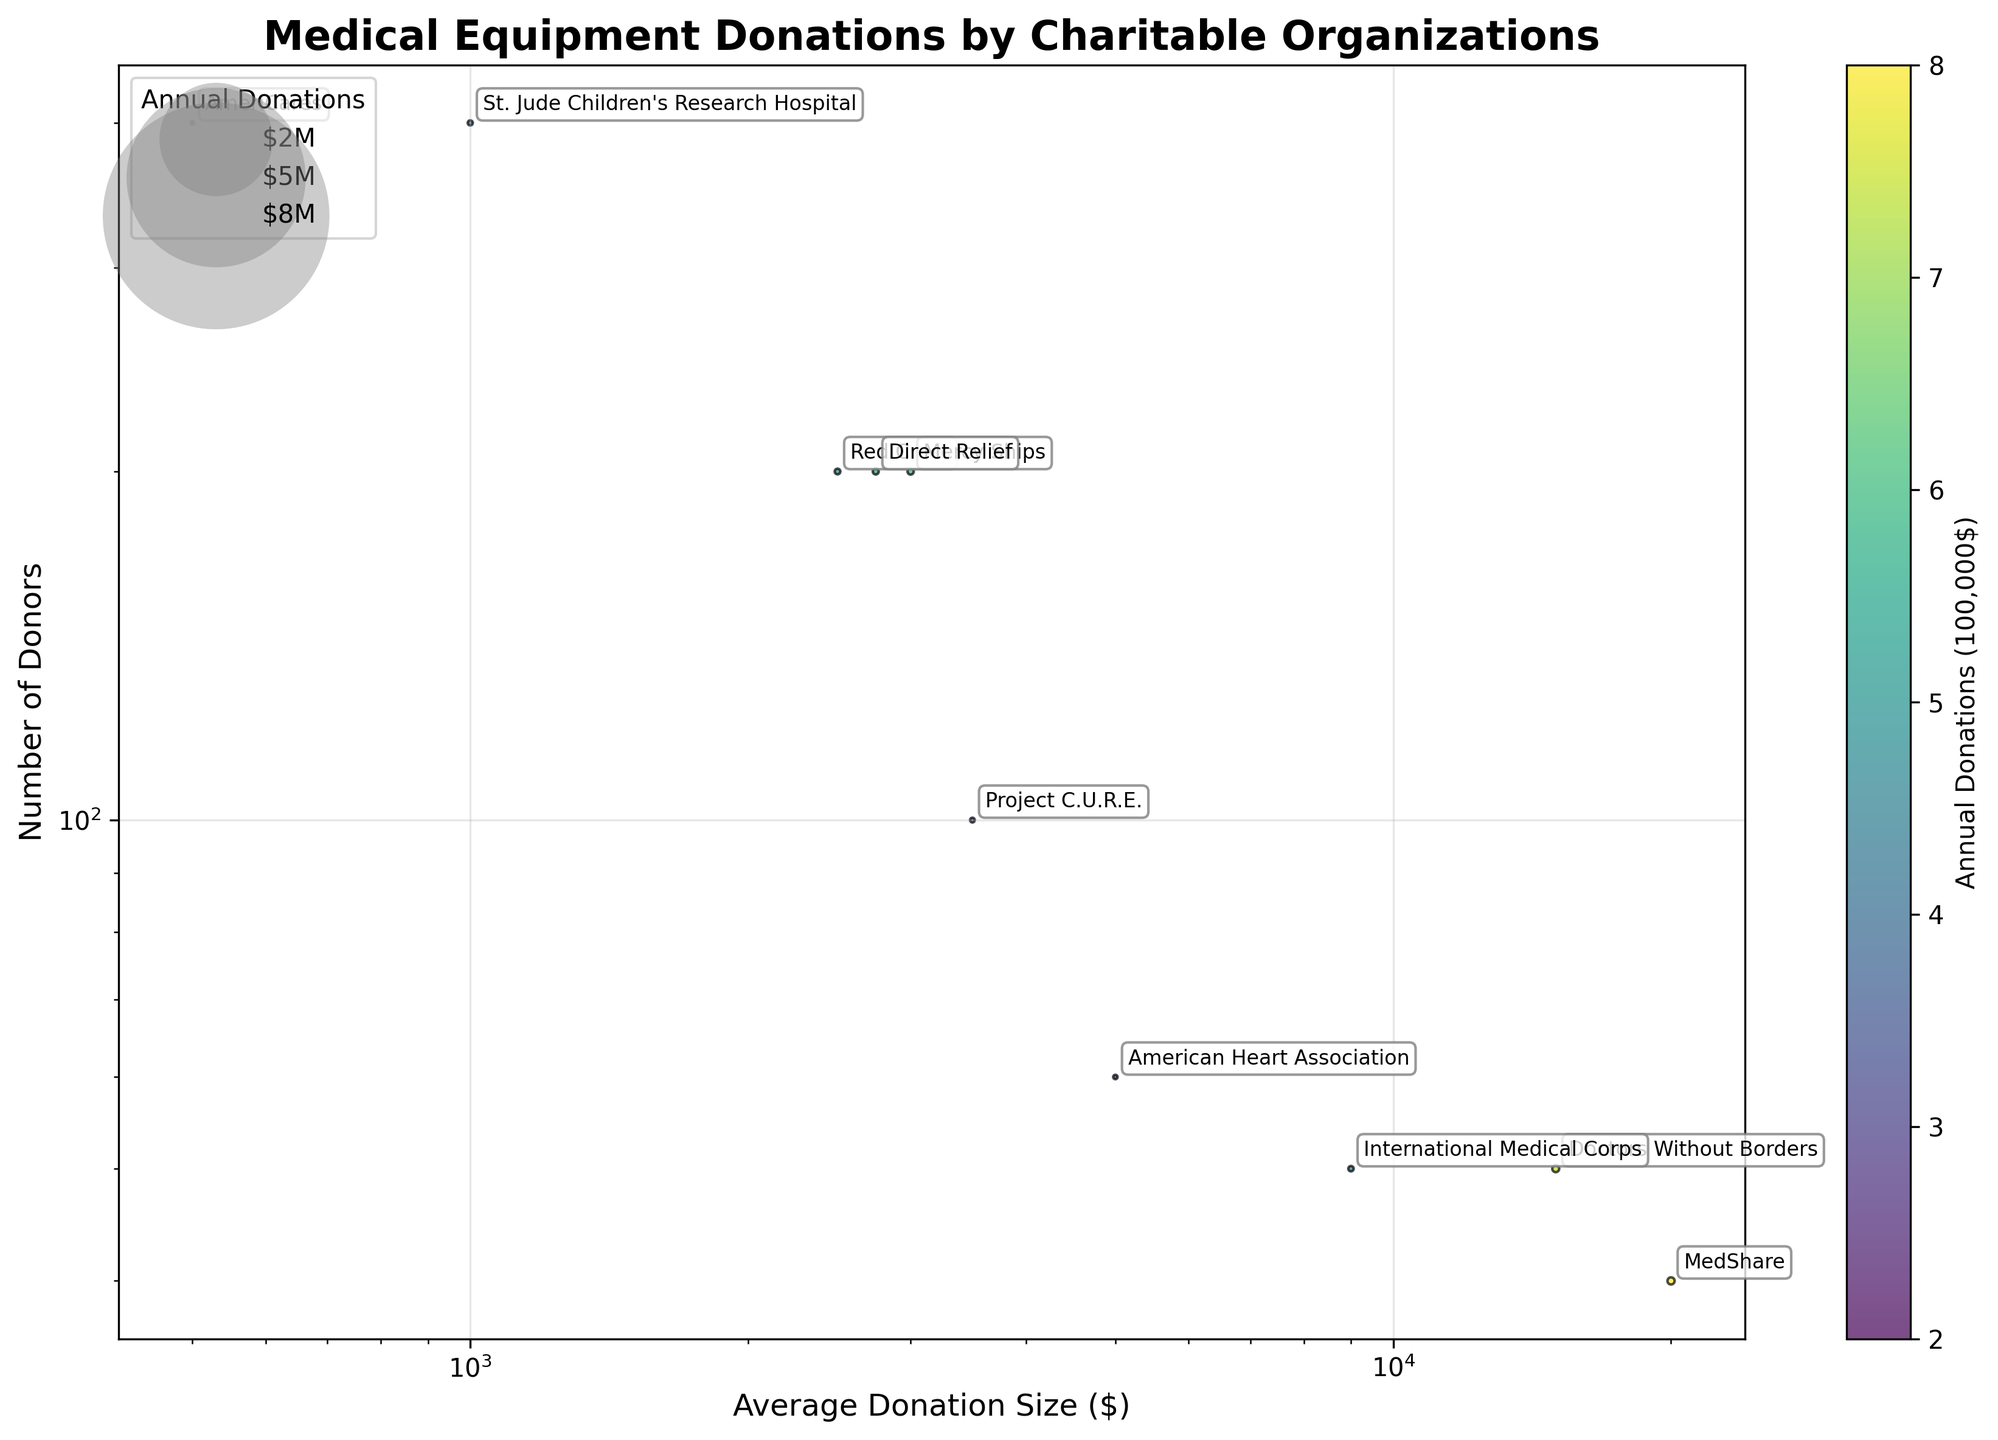what is the title of the plot? The title is a basic element of the figure that is usually displayed at the top. To identify it, simply look at the topmost text on the plot.
Answer: Medical Equipment Donations by Charitable Organizations What do the x-axis and y-axis represent? The x-axis and y-axis are key components of the plot. The x-axis label is 'Average Donation Size ($)' and the y-axis label is 'Number of Donors'.
Answer: x-axis: Average Donation Size, y-axis: Number of Donors Which organization has the highest number of donors? Look for the data point that is highest on the y-axis. The y-axis represents the number of donors.
Answer: AmeriCares Which organization has made the highest annual donations? The size of the bubble represents the annual donations. The largest bubble is the one representing the greatest donations.
Answer: Doctors Without Borders Which equipment type is associated with the smallest average donation size? Examine the x-axis and identify the smallest value, then check the corresponding equipment type.
Answer: Wheelchairs Between Red Cross and Direct Relief, which organization has more donors? Find both organizations on the plot and compare their positions on the y-axis, which represents the number of donors.
Answer: Red Cross Which organization has an average donation size between 3000 and 5000 dollars and more than 50 donors? Identify bubbles between 3000 and 5000 on the x-axis and above 50 on the y-axis, then check the corresponding organization.
Answer: Mercy Ships Comparing Red Cross and International Medical Corps, which organization has a smaller average donation size? Locate both organizations on the x-axis and compare their values. The one further to the left has the smaller average donation size.
Answer: Red Cross Which organization has the highest average donation size? Identify the data point farthest to the right on the x-axis, representing the highest average donation size.
Answer: MedShare What does the color of the bubbles represent? The plot includes a colorbar that indicates what attribute the color represents, which corresponds to annual donations.
Answer: Annual Donations 